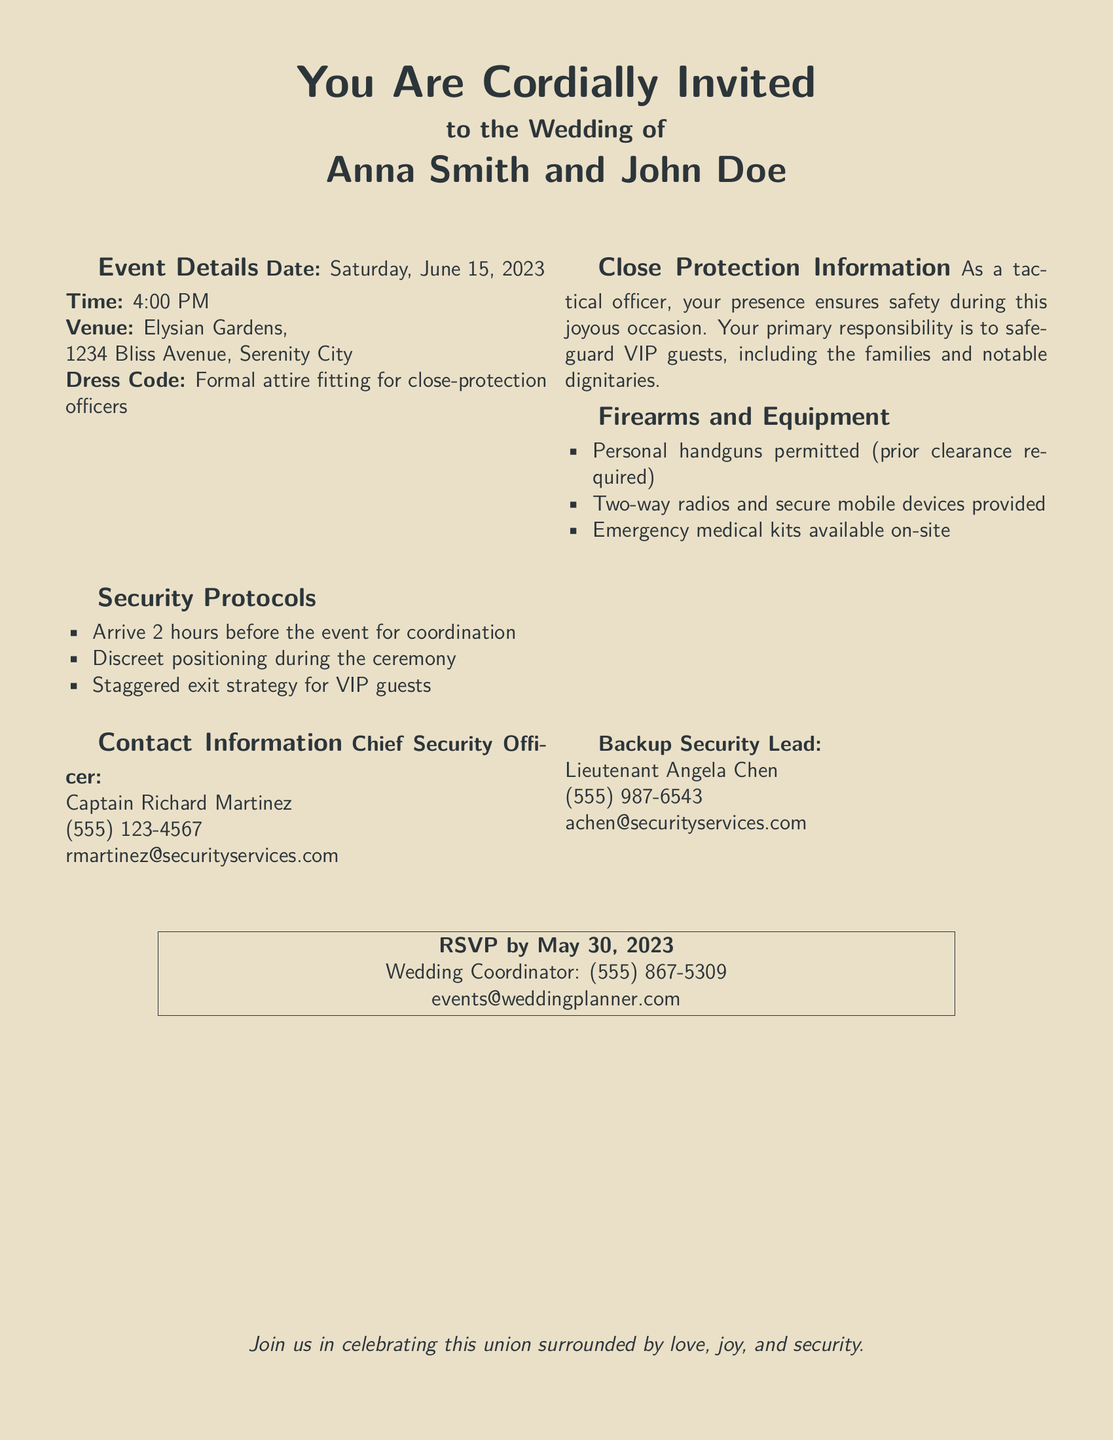What is the date of the wedding? The date is specifically mentioned in the event details of the document.
Answer: Saturday, June 15, 2023 What time does the wedding start? The time is clearly indicated in the event details section of the document.
Answer: 4:00 PM What is the venue of the wedding? The venue is listed under the event details section.
Answer: Elysian Gardens, 1234 Bliss Avenue, Serenity City Who is the Chief Security Officer? The name of the Chief Security Officer is provided in the contact information section.
Answer: Captain Richard Martinez What must be obtained before bringing firearms? The document specifies that permission is required prior to bringing prohibited items.
Answer: Prior clearance required What is the role of the tactical officers at the wedding? The role is described in the close protection information section.
Answer: Safeguard VIP guests When is the RSVP deadline? The RSVP date is mentioned explicitly at the bottom of the document.
Answer: May 30, 2023 Who should be contacted as the backup security lead? The name is provided under the contact information section of the document.
Answer: Lieutenant Angela Chen What attire is required for close-protection officers? The dress code is specifically stated in the event details.
Answer: Formal attire fitting for close-protection officers 